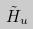Convert formula to latex. <formula><loc_0><loc_0><loc_500><loc_500>\tilde { H } _ { u }</formula> 